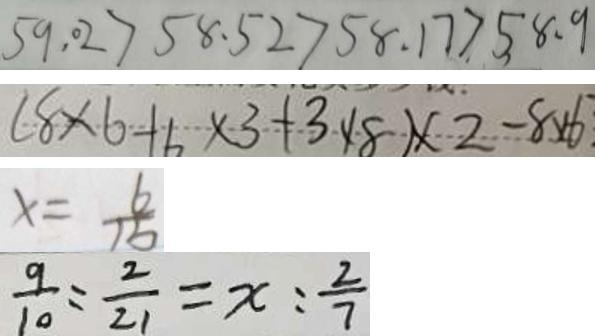<formula> <loc_0><loc_0><loc_500><loc_500>5 9 . 0 2 > 5 8 . 5 2 > 5 8 . 1 7 > 5 8 . 9 
 ( 8 \times 6 - 6 \times 3 + 3 \times 8 ) \times 2 - 8 \times 6 
 x = \frac { 6 } { 1 5 } 
 \frac { 9 } { 1 0 } = \frac { 2 } { 2 1 } = x : \frac { 2 } { 7 }</formula> 